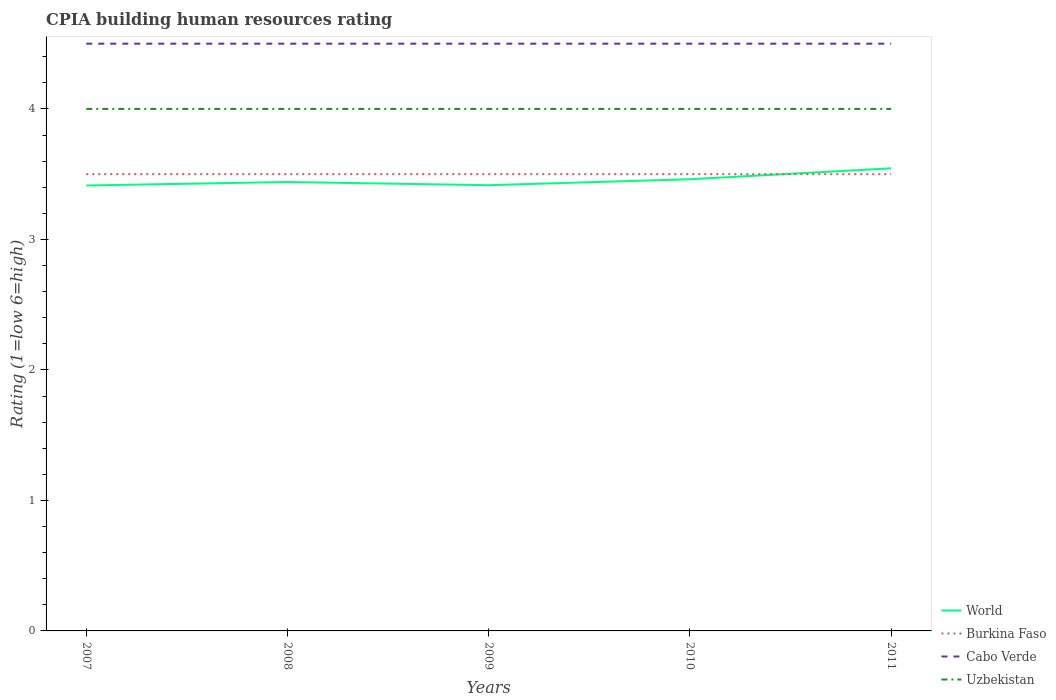How many different coloured lines are there?
Ensure brevity in your answer.  4. In which year was the CPIA rating in World maximum?
Provide a short and direct response. 2007. What is the difference between the highest and the second highest CPIA rating in World?
Give a very brief answer. 0.13. Is the CPIA rating in Uzbekistan strictly greater than the CPIA rating in Burkina Faso over the years?
Provide a short and direct response. No. How many lines are there?
Your answer should be compact. 4. Does the graph contain any zero values?
Give a very brief answer. No. How are the legend labels stacked?
Give a very brief answer. Vertical. What is the title of the graph?
Make the answer very short. CPIA building human resources rating. What is the label or title of the X-axis?
Keep it short and to the point. Years. What is the Rating (1=low 6=high) in World in 2007?
Your answer should be compact. 3.41. What is the Rating (1=low 6=high) of Cabo Verde in 2007?
Ensure brevity in your answer.  4.5. What is the Rating (1=low 6=high) in Uzbekistan in 2007?
Keep it short and to the point. 4. What is the Rating (1=low 6=high) of World in 2008?
Your answer should be compact. 3.44. What is the Rating (1=low 6=high) in Uzbekistan in 2008?
Make the answer very short. 4. What is the Rating (1=low 6=high) of World in 2009?
Keep it short and to the point. 3.42. What is the Rating (1=low 6=high) of Uzbekistan in 2009?
Keep it short and to the point. 4. What is the Rating (1=low 6=high) of World in 2010?
Ensure brevity in your answer.  3.46. What is the Rating (1=low 6=high) of Cabo Verde in 2010?
Your response must be concise. 4.5. What is the Rating (1=low 6=high) of World in 2011?
Make the answer very short. 3.54. What is the Rating (1=low 6=high) of Cabo Verde in 2011?
Ensure brevity in your answer.  4.5. Across all years, what is the maximum Rating (1=low 6=high) of World?
Give a very brief answer. 3.54. Across all years, what is the maximum Rating (1=low 6=high) of Burkina Faso?
Provide a succinct answer. 3.5. Across all years, what is the maximum Rating (1=low 6=high) in Cabo Verde?
Provide a short and direct response. 4.5. Across all years, what is the minimum Rating (1=low 6=high) in World?
Keep it short and to the point. 3.41. Across all years, what is the minimum Rating (1=low 6=high) of Cabo Verde?
Your answer should be compact. 4.5. What is the total Rating (1=low 6=high) in World in the graph?
Keep it short and to the point. 17.27. What is the total Rating (1=low 6=high) in Burkina Faso in the graph?
Your answer should be very brief. 17.5. What is the total Rating (1=low 6=high) in Uzbekistan in the graph?
Your answer should be compact. 20. What is the difference between the Rating (1=low 6=high) of World in 2007 and that in 2008?
Give a very brief answer. -0.03. What is the difference between the Rating (1=low 6=high) of Cabo Verde in 2007 and that in 2008?
Give a very brief answer. 0. What is the difference between the Rating (1=low 6=high) in World in 2007 and that in 2009?
Provide a short and direct response. -0. What is the difference between the Rating (1=low 6=high) of Burkina Faso in 2007 and that in 2009?
Keep it short and to the point. 0. What is the difference between the Rating (1=low 6=high) of Cabo Verde in 2007 and that in 2009?
Your answer should be compact. 0. What is the difference between the Rating (1=low 6=high) of World in 2007 and that in 2010?
Your response must be concise. -0.05. What is the difference between the Rating (1=low 6=high) of Burkina Faso in 2007 and that in 2010?
Ensure brevity in your answer.  0. What is the difference between the Rating (1=low 6=high) in World in 2007 and that in 2011?
Offer a terse response. -0.13. What is the difference between the Rating (1=low 6=high) in Burkina Faso in 2007 and that in 2011?
Offer a very short reply. 0. What is the difference between the Rating (1=low 6=high) of Uzbekistan in 2007 and that in 2011?
Give a very brief answer. 0. What is the difference between the Rating (1=low 6=high) of World in 2008 and that in 2009?
Ensure brevity in your answer.  0.02. What is the difference between the Rating (1=low 6=high) in Cabo Verde in 2008 and that in 2009?
Your answer should be compact. 0. What is the difference between the Rating (1=low 6=high) in World in 2008 and that in 2010?
Your response must be concise. -0.02. What is the difference between the Rating (1=low 6=high) in Uzbekistan in 2008 and that in 2010?
Provide a succinct answer. 0. What is the difference between the Rating (1=low 6=high) of World in 2008 and that in 2011?
Provide a succinct answer. -0.1. What is the difference between the Rating (1=low 6=high) in Cabo Verde in 2008 and that in 2011?
Offer a terse response. 0. What is the difference between the Rating (1=low 6=high) in World in 2009 and that in 2010?
Offer a terse response. -0.05. What is the difference between the Rating (1=low 6=high) in Burkina Faso in 2009 and that in 2010?
Provide a short and direct response. 0. What is the difference between the Rating (1=low 6=high) in Cabo Verde in 2009 and that in 2010?
Your response must be concise. 0. What is the difference between the Rating (1=low 6=high) of World in 2009 and that in 2011?
Give a very brief answer. -0.13. What is the difference between the Rating (1=low 6=high) of Cabo Verde in 2009 and that in 2011?
Give a very brief answer. 0. What is the difference between the Rating (1=low 6=high) in Uzbekistan in 2009 and that in 2011?
Provide a succinct answer. 0. What is the difference between the Rating (1=low 6=high) in World in 2010 and that in 2011?
Ensure brevity in your answer.  -0.08. What is the difference between the Rating (1=low 6=high) in Burkina Faso in 2010 and that in 2011?
Make the answer very short. 0. What is the difference between the Rating (1=low 6=high) in World in 2007 and the Rating (1=low 6=high) in Burkina Faso in 2008?
Provide a short and direct response. -0.09. What is the difference between the Rating (1=low 6=high) of World in 2007 and the Rating (1=low 6=high) of Cabo Verde in 2008?
Offer a terse response. -1.09. What is the difference between the Rating (1=low 6=high) of World in 2007 and the Rating (1=low 6=high) of Uzbekistan in 2008?
Offer a terse response. -0.59. What is the difference between the Rating (1=low 6=high) of Burkina Faso in 2007 and the Rating (1=low 6=high) of Cabo Verde in 2008?
Your answer should be very brief. -1. What is the difference between the Rating (1=low 6=high) of World in 2007 and the Rating (1=low 6=high) of Burkina Faso in 2009?
Provide a short and direct response. -0.09. What is the difference between the Rating (1=low 6=high) of World in 2007 and the Rating (1=low 6=high) of Cabo Verde in 2009?
Offer a very short reply. -1.09. What is the difference between the Rating (1=low 6=high) of World in 2007 and the Rating (1=low 6=high) of Uzbekistan in 2009?
Your response must be concise. -0.59. What is the difference between the Rating (1=low 6=high) in Burkina Faso in 2007 and the Rating (1=low 6=high) in Uzbekistan in 2009?
Your answer should be very brief. -0.5. What is the difference between the Rating (1=low 6=high) of World in 2007 and the Rating (1=low 6=high) of Burkina Faso in 2010?
Make the answer very short. -0.09. What is the difference between the Rating (1=low 6=high) in World in 2007 and the Rating (1=low 6=high) in Cabo Verde in 2010?
Provide a short and direct response. -1.09. What is the difference between the Rating (1=low 6=high) of World in 2007 and the Rating (1=low 6=high) of Uzbekistan in 2010?
Ensure brevity in your answer.  -0.59. What is the difference between the Rating (1=low 6=high) in Burkina Faso in 2007 and the Rating (1=low 6=high) in Cabo Verde in 2010?
Make the answer very short. -1. What is the difference between the Rating (1=low 6=high) in Burkina Faso in 2007 and the Rating (1=low 6=high) in Uzbekistan in 2010?
Your response must be concise. -0.5. What is the difference between the Rating (1=low 6=high) of World in 2007 and the Rating (1=low 6=high) of Burkina Faso in 2011?
Make the answer very short. -0.09. What is the difference between the Rating (1=low 6=high) of World in 2007 and the Rating (1=low 6=high) of Cabo Verde in 2011?
Provide a short and direct response. -1.09. What is the difference between the Rating (1=low 6=high) of World in 2007 and the Rating (1=low 6=high) of Uzbekistan in 2011?
Your answer should be compact. -0.59. What is the difference between the Rating (1=low 6=high) of Burkina Faso in 2007 and the Rating (1=low 6=high) of Uzbekistan in 2011?
Your answer should be very brief. -0.5. What is the difference between the Rating (1=low 6=high) in Cabo Verde in 2007 and the Rating (1=low 6=high) in Uzbekistan in 2011?
Make the answer very short. 0.5. What is the difference between the Rating (1=low 6=high) in World in 2008 and the Rating (1=low 6=high) in Burkina Faso in 2009?
Make the answer very short. -0.06. What is the difference between the Rating (1=low 6=high) of World in 2008 and the Rating (1=low 6=high) of Cabo Verde in 2009?
Provide a short and direct response. -1.06. What is the difference between the Rating (1=low 6=high) of World in 2008 and the Rating (1=low 6=high) of Uzbekistan in 2009?
Offer a very short reply. -0.56. What is the difference between the Rating (1=low 6=high) in Burkina Faso in 2008 and the Rating (1=low 6=high) in Cabo Verde in 2009?
Offer a very short reply. -1. What is the difference between the Rating (1=low 6=high) in Cabo Verde in 2008 and the Rating (1=low 6=high) in Uzbekistan in 2009?
Offer a terse response. 0.5. What is the difference between the Rating (1=low 6=high) of World in 2008 and the Rating (1=low 6=high) of Burkina Faso in 2010?
Your response must be concise. -0.06. What is the difference between the Rating (1=low 6=high) in World in 2008 and the Rating (1=low 6=high) in Cabo Verde in 2010?
Provide a succinct answer. -1.06. What is the difference between the Rating (1=low 6=high) in World in 2008 and the Rating (1=low 6=high) in Uzbekistan in 2010?
Provide a succinct answer. -0.56. What is the difference between the Rating (1=low 6=high) of World in 2008 and the Rating (1=low 6=high) of Burkina Faso in 2011?
Your response must be concise. -0.06. What is the difference between the Rating (1=low 6=high) of World in 2008 and the Rating (1=low 6=high) of Cabo Verde in 2011?
Make the answer very short. -1.06. What is the difference between the Rating (1=low 6=high) of World in 2008 and the Rating (1=low 6=high) of Uzbekistan in 2011?
Ensure brevity in your answer.  -0.56. What is the difference between the Rating (1=low 6=high) of World in 2009 and the Rating (1=low 6=high) of Burkina Faso in 2010?
Your answer should be very brief. -0.08. What is the difference between the Rating (1=low 6=high) of World in 2009 and the Rating (1=low 6=high) of Cabo Verde in 2010?
Give a very brief answer. -1.08. What is the difference between the Rating (1=low 6=high) of World in 2009 and the Rating (1=low 6=high) of Uzbekistan in 2010?
Make the answer very short. -0.58. What is the difference between the Rating (1=low 6=high) of Burkina Faso in 2009 and the Rating (1=low 6=high) of Cabo Verde in 2010?
Your answer should be compact. -1. What is the difference between the Rating (1=low 6=high) in World in 2009 and the Rating (1=low 6=high) in Burkina Faso in 2011?
Offer a very short reply. -0.08. What is the difference between the Rating (1=low 6=high) of World in 2009 and the Rating (1=low 6=high) of Cabo Verde in 2011?
Give a very brief answer. -1.08. What is the difference between the Rating (1=low 6=high) in World in 2009 and the Rating (1=low 6=high) in Uzbekistan in 2011?
Ensure brevity in your answer.  -0.58. What is the difference between the Rating (1=low 6=high) in Cabo Verde in 2009 and the Rating (1=low 6=high) in Uzbekistan in 2011?
Your answer should be very brief. 0.5. What is the difference between the Rating (1=low 6=high) of World in 2010 and the Rating (1=low 6=high) of Burkina Faso in 2011?
Give a very brief answer. -0.04. What is the difference between the Rating (1=low 6=high) of World in 2010 and the Rating (1=low 6=high) of Cabo Verde in 2011?
Ensure brevity in your answer.  -1.04. What is the difference between the Rating (1=low 6=high) of World in 2010 and the Rating (1=low 6=high) of Uzbekistan in 2011?
Provide a succinct answer. -0.54. What is the difference between the Rating (1=low 6=high) of Burkina Faso in 2010 and the Rating (1=low 6=high) of Cabo Verde in 2011?
Offer a very short reply. -1. What is the difference between the Rating (1=low 6=high) of Burkina Faso in 2010 and the Rating (1=low 6=high) of Uzbekistan in 2011?
Your answer should be compact. -0.5. What is the average Rating (1=low 6=high) of World per year?
Keep it short and to the point. 3.46. What is the average Rating (1=low 6=high) in Cabo Verde per year?
Provide a short and direct response. 4.5. What is the average Rating (1=low 6=high) in Uzbekistan per year?
Make the answer very short. 4. In the year 2007, what is the difference between the Rating (1=low 6=high) of World and Rating (1=low 6=high) of Burkina Faso?
Offer a very short reply. -0.09. In the year 2007, what is the difference between the Rating (1=low 6=high) of World and Rating (1=low 6=high) of Cabo Verde?
Your answer should be compact. -1.09. In the year 2007, what is the difference between the Rating (1=low 6=high) of World and Rating (1=low 6=high) of Uzbekistan?
Give a very brief answer. -0.59. In the year 2007, what is the difference between the Rating (1=low 6=high) of Burkina Faso and Rating (1=low 6=high) of Cabo Verde?
Provide a short and direct response. -1. In the year 2007, what is the difference between the Rating (1=low 6=high) of Burkina Faso and Rating (1=low 6=high) of Uzbekistan?
Offer a very short reply. -0.5. In the year 2008, what is the difference between the Rating (1=low 6=high) in World and Rating (1=low 6=high) in Burkina Faso?
Your response must be concise. -0.06. In the year 2008, what is the difference between the Rating (1=low 6=high) in World and Rating (1=low 6=high) in Cabo Verde?
Make the answer very short. -1.06. In the year 2008, what is the difference between the Rating (1=low 6=high) in World and Rating (1=low 6=high) in Uzbekistan?
Ensure brevity in your answer.  -0.56. In the year 2008, what is the difference between the Rating (1=low 6=high) of Burkina Faso and Rating (1=low 6=high) of Cabo Verde?
Keep it short and to the point. -1. In the year 2008, what is the difference between the Rating (1=low 6=high) in Burkina Faso and Rating (1=low 6=high) in Uzbekistan?
Ensure brevity in your answer.  -0.5. In the year 2009, what is the difference between the Rating (1=low 6=high) of World and Rating (1=low 6=high) of Burkina Faso?
Keep it short and to the point. -0.08. In the year 2009, what is the difference between the Rating (1=low 6=high) of World and Rating (1=low 6=high) of Cabo Verde?
Provide a succinct answer. -1.08. In the year 2009, what is the difference between the Rating (1=low 6=high) in World and Rating (1=low 6=high) in Uzbekistan?
Make the answer very short. -0.58. In the year 2010, what is the difference between the Rating (1=low 6=high) of World and Rating (1=low 6=high) of Burkina Faso?
Your answer should be compact. -0.04. In the year 2010, what is the difference between the Rating (1=low 6=high) of World and Rating (1=low 6=high) of Cabo Verde?
Give a very brief answer. -1.04. In the year 2010, what is the difference between the Rating (1=low 6=high) in World and Rating (1=low 6=high) in Uzbekistan?
Give a very brief answer. -0.54. In the year 2010, what is the difference between the Rating (1=low 6=high) of Burkina Faso and Rating (1=low 6=high) of Uzbekistan?
Provide a short and direct response. -0.5. In the year 2010, what is the difference between the Rating (1=low 6=high) of Cabo Verde and Rating (1=low 6=high) of Uzbekistan?
Your answer should be compact. 0.5. In the year 2011, what is the difference between the Rating (1=low 6=high) of World and Rating (1=low 6=high) of Burkina Faso?
Your answer should be very brief. 0.04. In the year 2011, what is the difference between the Rating (1=low 6=high) in World and Rating (1=low 6=high) in Cabo Verde?
Give a very brief answer. -0.96. In the year 2011, what is the difference between the Rating (1=low 6=high) of World and Rating (1=low 6=high) of Uzbekistan?
Your answer should be very brief. -0.46. In the year 2011, what is the difference between the Rating (1=low 6=high) of Burkina Faso and Rating (1=low 6=high) of Uzbekistan?
Offer a terse response. -0.5. In the year 2011, what is the difference between the Rating (1=low 6=high) of Cabo Verde and Rating (1=low 6=high) of Uzbekistan?
Offer a terse response. 0.5. What is the ratio of the Rating (1=low 6=high) in Cabo Verde in 2007 to that in 2008?
Provide a short and direct response. 1. What is the ratio of the Rating (1=low 6=high) in World in 2007 to that in 2009?
Give a very brief answer. 1. What is the ratio of the Rating (1=low 6=high) of World in 2007 to that in 2010?
Ensure brevity in your answer.  0.99. What is the ratio of the Rating (1=low 6=high) of Burkina Faso in 2007 to that in 2010?
Your answer should be compact. 1. What is the ratio of the Rating (1=low 6=high) of World in 2007 to that in 2011?
Your answer should be very brief. 0.96. What is the ratio of the Rating (1=low 6=high) in Cabo Verde in 2007 to that in 2011?
Provide a succinct answer. 1. What is the ratio of the Rating (1=low 6=high) of World in 2008 to that in 2009?
Provide a short and direct response. 1.01. What is the ratio of the Rating (1=low 6=high) of Uzbekistan in 2008 to that in 2009?
Your answer should be very brief. 1. What is the ratio of the Rating (1=low 6=high) in World in 2008 to that in 2010?
Give a very brief answer. 0.99. What is the ratio of the Rating (1=low 6=high) in Cabo Verde in 2008 to that in 2010?
Provide a short and direct response. 1. What is the ratio of the Rating (1=low 6=high) in Uzbekistan in 2008 to that in 2010?
Keep it short and to the point. 1. What is the ratio of the Rating (1=low 6=high) in World in 2008 to that in 2011?
Offer a very short reply. 0.97. What is the ratio of the Rating (1=low 6=high) in Burkina Faso in 2008 to that in 2011?
Provide a succinct answer. 1. What is the ratio of the Rating (1=low 6=high) of Cabo Verde in 2008 to that in 2011?
Your answer should be compact. 1. What is the ratio of the Rating (1=low 6=high) of Uzbekistan in 2008 to that in 2011?
Make the answer very short. 1. What is the ratio of the Rating (1=low 6=high) of World in 2009 to that in 2010?
Give a very brief answer. 0.99. What is the ratio of the Rating (1=low 6=high) of Cabo Verde in 2009 to that in 2010?
Your answer should be very brief. 1. What is the ratio of the Rating (1=low 6=high) of Uzbekistan in 2009 to that in 2010?
Provide a succinct answer. 1. What is the ratio of the Rating (1=low 6=high) in World in 2009 to that in 2011?
Your answer should be compact. 0.96. What is the ratio of the Rating (1=low 6=high) of Burkina Faso in 2009 to that in 2011?
Keep it short and to the point. 1. What is the ratio of the Rating (1=low 6=high) of Cabo Verde in 2009 to that in 2011?
Your response must be concise. 1. What is the ratio of the Rating (1=low 6=high) in Uzbekistan in 2009 to that in 2011?
Your answer should be compact. 1. What is the ratio of the Rating (1=low 6=high) in World in 2010 to that in 2011?
Your answer should be very brief. 0.98. What is the ratio of the Rating (1=low 6=high) in Cabo Verde in 2010 to that in 2011?
Ensure brevity in your answer.  1. What is the ratio of the Rating (1=low 6=high) of Uzbekistan in 2010 to that in 2011?
Offer a terse response. 1. What is the difference between the highest and the second highest Rating (1=low 6=high) of World?
Provide a succinct answer. 0.08. What is the difference between the highest and the second highest Rating (1=low 6=high) in Burkina Faso?
Give a very brief answer. 0. What is the difference between the highest and the second highest Rating (1=low 6=high) of Uzbekistan?
Offer a terse response. 0. What is the difference between the highest and the lowest Rating (1=low 6=high) in World?
Give a very brief answer. 0.13. What is the difference between the highest and the lowest Rating (1=low 6=high) of Uzbekistan?
Your answer should be very brief. 0. 